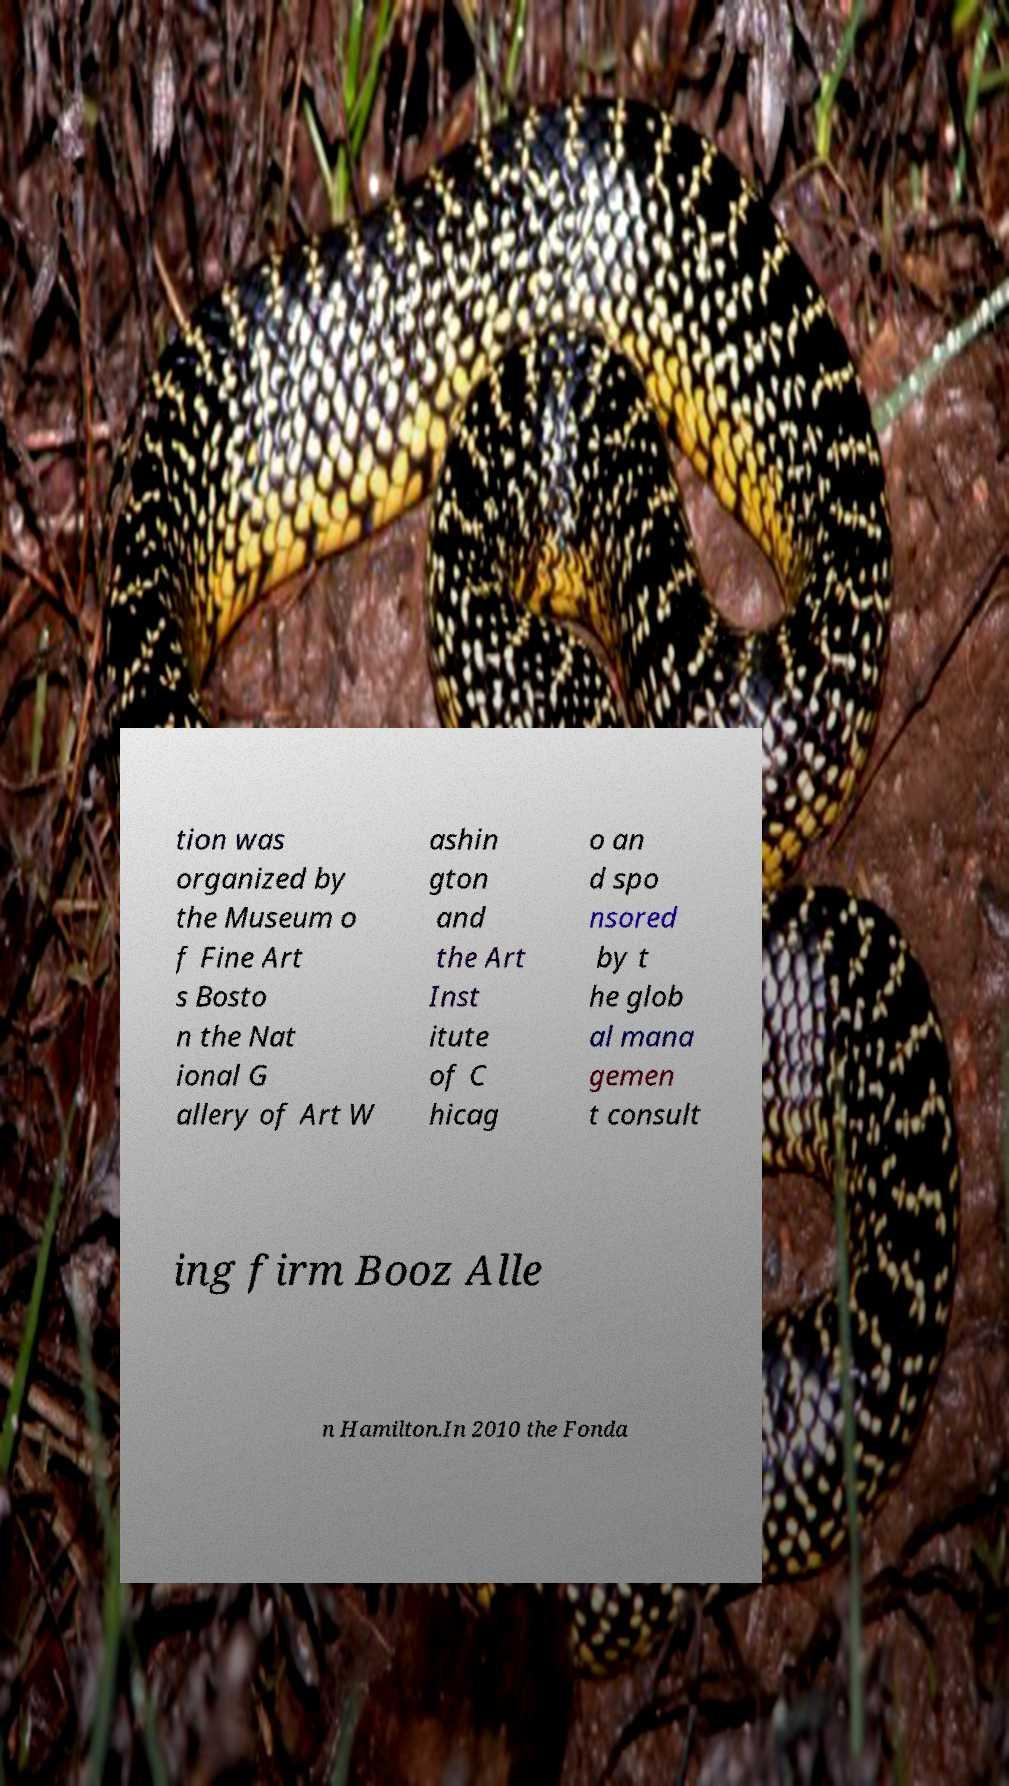Could you extract and type out the text from this image? tion was organized by the Museum o f Fine Art s Bosto n the Nat ional G allery of Art W ashin gton and the Art Inst itute of C hicag o an d spo nsored by t he glob al mana gemen t consult ing firm Booz Alle n Hamilton.In 2010 the Fonda 